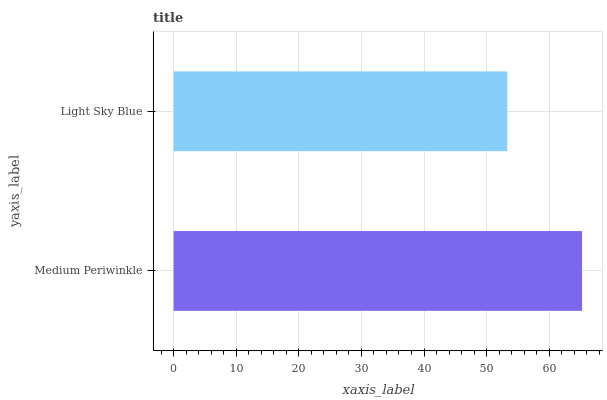Is Light Sky Blue the minimum?
Answer yes or no. Yes. Is Medium Periwinkle the maximum?
Answer yes or no. Yes. Is Light Sky Blue the maximum?
Answer yes or no. No. Is Medium Periwinkle greater than Light Sky Blue?
Answer yes or no. Yes. Is Light Sky Blue less than Medium Periwinkle?
Answer yes or no. Yes. Is Light Sky Blue greater than Medium Periwinkle?
Answer yes or no. No. Is Medium Periwinkle less than Light Sky Blue?
Answer yes or no. No. Is Medium Periwinkle the high median?
Answer yes or no. Yes. Is Light Sky Blue the low median?
Answer yes or no. Yes. Is Light Sky Blue the high median?
Answer yes or no. No. Is Medium Periwinkle the low median?
Answer yes or no. No. 